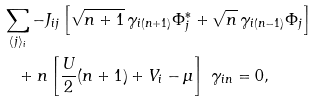<formula> <loc_0><loc_0><loc_500><loc_500>& \, \sum _ { \langle j \rangle _ { i } } - J _ { i j } \left [ \sqrt { n + 1 } \, \gamma _ { i ( n + 1 ) } \Phi _ { j } ^ { * } + \sqrt { n } \, \gamma _ { i ( n - 1 ) } \Phi _ { j } \right ] \\ & \quad + n \left [ \frac { U } { 2 } ( n + 1 ) + V _ { i } - \mu \right ] \ \gamma _ { i n } = 0 ,</formula> 